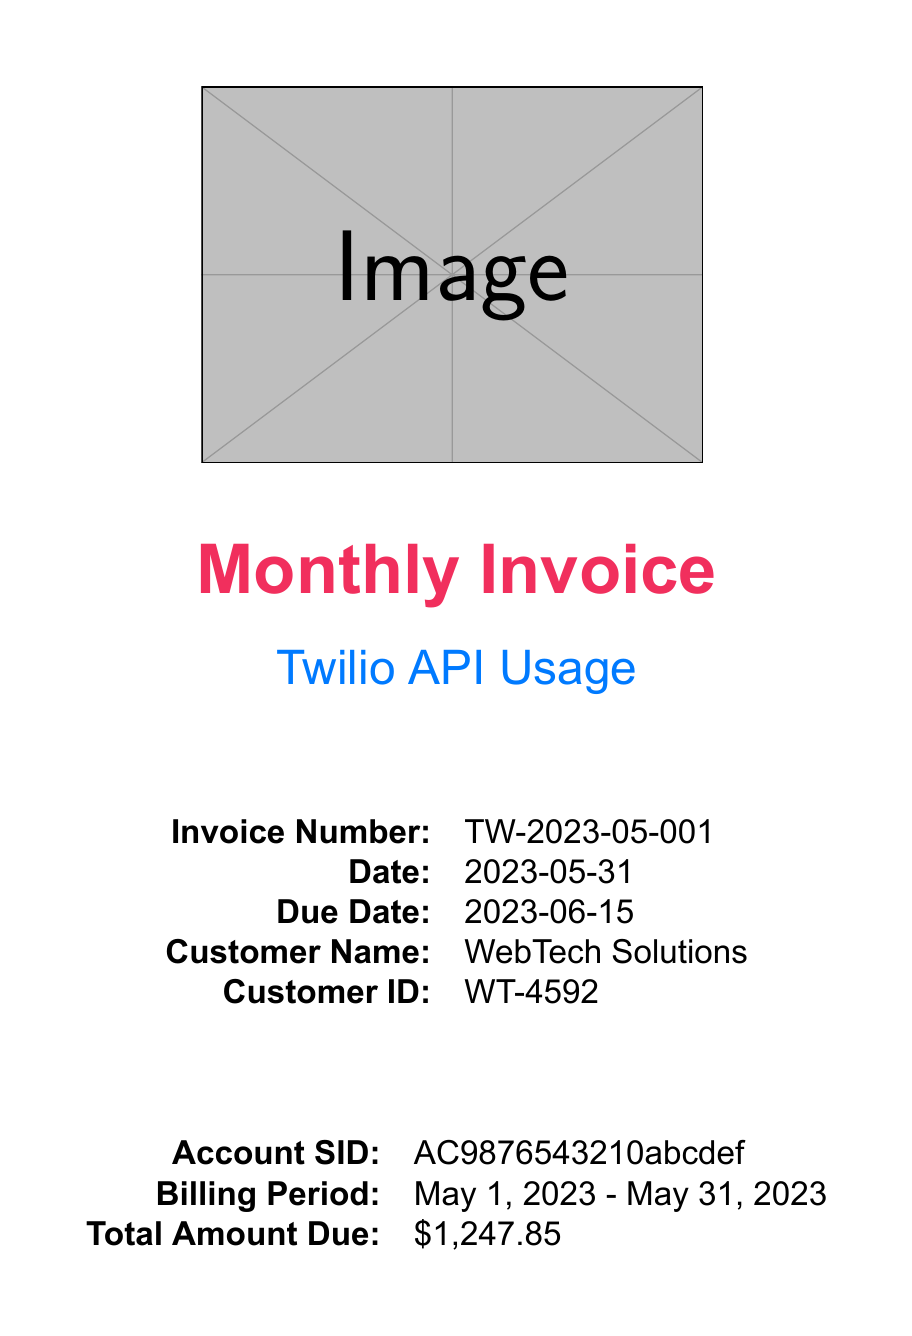what is the invoice number? The invoice number is clearly stated in the document under invoice details.
Answer: TW-2023-05-001 what is the total amount due? The total amount due is specified in the account summary section of the invoice.
Answer: $1,247.85 how many inbound SMS messages were received? The number of inbound SMS messages is detailed in the service charges under the SMS category.
Answer: 7,500 what percentage of video usage was recorded minutes? The percentage can be calculated based on the total participant minutes and total recorded minutes provided in the usage breakdown.
Answer: 33.33% who is the account manager? The account manager's name is mentioned in the support information section of the invoice.
Answer: Sarah Johnson what is the due date for payment? The due date is listed in the invoice details section.
Answer: 2023-06-15 how many outbound voice minutes were utilized? The usage of outbound voice minutes is recorded in the service charges section.
Answer: 1,200 which payment method was used? This information is found in the payment information section of the invoice.
Answer: Credit Card what is the billing period? The billing period is stated in the account summary in the document.
Answer: May 1, 2023 - May 31, 2023 